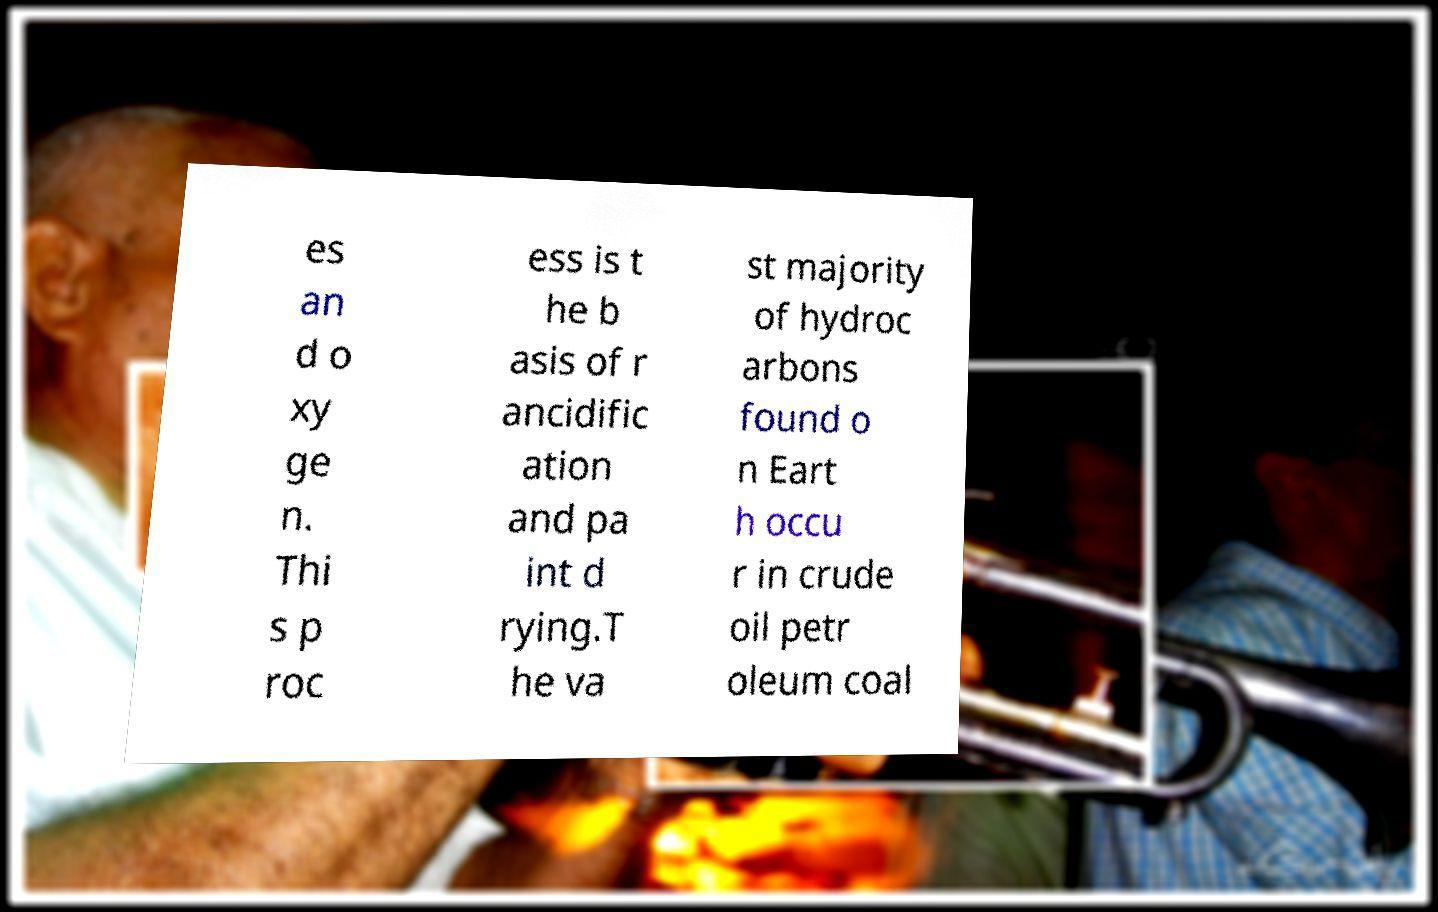Could you extract and type out the text from this image? es an d o xy ge n. Thi s p roc ess is t he b asis of r ancidific ation and pa int d rying.T he va st majority of hydroc arbons found o n Eart h occu r in crude oil petr oleum coal 